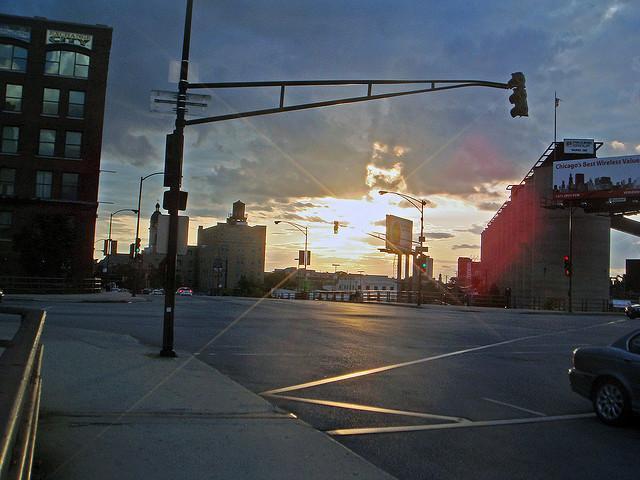How many billboards is in the scene?
Give a very brief answer. 2. How many cars are at the intersection?
Give a very brief answer. 1. How many cars are crossing the street?
Give a very brief answer. 1. 